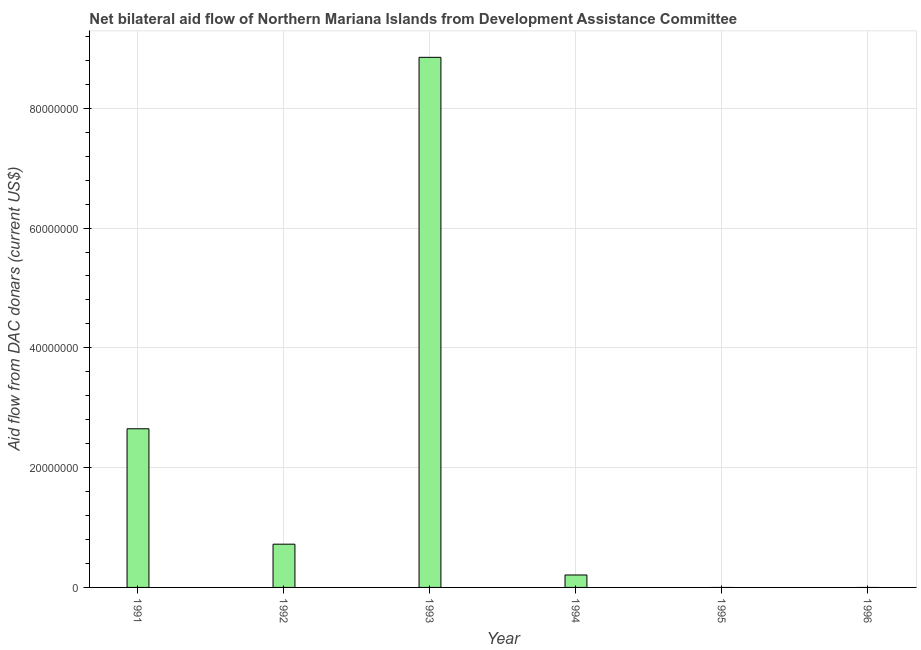What is the title of the graph?
Ensure brevity in your answer.  Net bilateral aid flow of Northern Mariana Islands from Development Assistance Committee. What is the label or title of the X-axis?
Provide a succinct answer. Year. What is the label or title of the Y-axis?
Give a very brief answer. Aid flow from DAC donars (current US$). What is the net bilateral aid flows from dac donors in 1994?
Make the answer very short. 2.08e+06. Across all years, what is the maximum net bilateral aid flows from dac donors?
Your response must be concise. 8.85e+07. What is the sum of the net bilateral aid flows from dac donors?
Your answer should be very brief. 1.24e+08. What is the difference between the net bilateral aid flows from dac donors in 1991 and 1994?
Provide a short and direct response. 2.44e+07. What is the average net bilateral aid flows from dac donors per year?
Your response must be concise. 2.07e+07. What is the median net bilateral aid flows from dac donors?
Provide a succinct answer. 4.65e+06. In how many years, is the net bilateral aid flows from dac donors greater than 16000000 US$?
Offer a very short reply. 2. What is the ratio of the net bilateral aid flows from dac donors in 1991 to that in 1994?
Offer a very short reply. 12.74. Is the net bilateral aid flows from dac donors in 1991 less than that in 1994?
Give a very brief answer. No. Is the difference between the net bilateral aid flows from dac donors in 1991 and 1994 greater than the difference between any two years?
Your response must be concise. No. What is the difference between the highest and the second highest net bilateral aid flows from dac donors?
Give a very brief answer. 6.20e+07. What is the difference between the highest and the lowest net bilateral aid flows from dac donors?
Your response must be concise. 8.85e+07. In how many years, is the net bilateral aid flows from dac donors greater than the average net bilateral aid flows from dac donors taken over all years?
Give a very brief answer. 2. How many bars are there?
Make the answer very short. 4. What is the Aid flow from DAC donars (current US$) in 1991?
Keep it short and to the point. 2.65e+07. What is the Aid flow from DAC donars (current US$) of 1992?
Ensure brevity in your answer.  7.22e+06. What is the Aid flow from DAC donars (current US$) of 1993?
Provide a succinct answer. 8.85e+07. What is the Aid flow from DAC donars (current US$) in 1994?
Offer a very short reply. 2.08e+06. What is the Aid flow from DAC donars (current US$) in 1995?
Make the answer very short. 0. What is the Aid flow from DAC donars (current US$) in 1996?
Ensure brevity in your answer.  0. What is the difference between the Aid flow from DAC donars (current US$) in 1991 and 1992?
Your answer should be compact. 1.93e+07. What is the difference between the Aid flow from DAC donars (current US$) in 1991 and 1993?
Provide a succinct answer. -6.20e+07. What is the difference between the Aid flow from DAC donars (current US$) in 1991 and 1994?
Make the answer very short. 2.44e+07. What is the difference between the Aid flow from DAC donars (current US$) in 1992 and 1993?
Offer a terse response. -8.13e+07. What is the difference between the Aid flow from DAC donars (current US$) in 1992 and 1994?
Offer a very short reply. 5.14e+06. What is the difference between the Aid flow from DAC donars (current US$) in 1993 and 1994?
Ensure brevity in your answer.  8.64e+07. What is the ratio of the Aid flow from DAC donars (current US$) in 1991 to that in 1992?
Make the answer very short. 3.67. What is the ratio of the Aid flow from DAC donars (current US$) in 1991 to that in 1993?
Ensure brevity in your answer.  0.3. What is the ratio of the Aid flow from DAC donars (current US$) in 1991 to that in 1994?
Give a very brief answer. 12.74. What is the ratio of the Aid flow from DAC donars (current US$) in 1992 to that in 1993?
Your answer should be very brief. 0.08. What is the ratio of the Aid flow from DAC donars (current US$) in 1992 to that in 1994?
Keep it short and to the point. 3.47. What is the ratio of the Aid flow from DAC donars (current US$) in 1993 to that in 1994?
Make the answer very short. 42.55. 